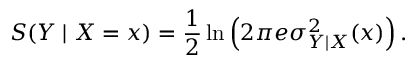<formula> <loc_0><loc_0><loc_500><loc_500>S ( Y | X = x ) = \frac { 1 } { 2 } \ln \left ( 2 \pi e \sigma _ { Y | X } ^ { 2 } ( x ) \right ) .</formula> 